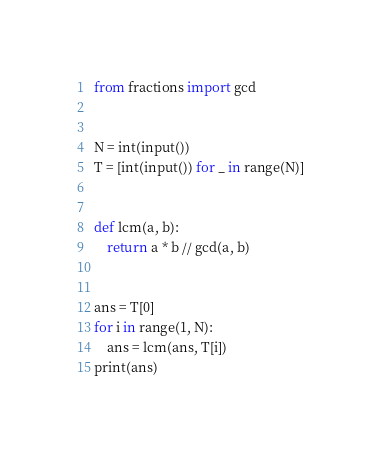<code> <loc_0><loc_0><loc_500><loc_500><_Python_>from fractions import gcd


N = int(input())
T = [int(input()) for _ in range(N)]


def lcm(a, b):
    return a * b // gcd(a, b)


ans = T[0]
for i in range(1, N):
    ans = lcm(ans, T[i])
print(ans)</code> 